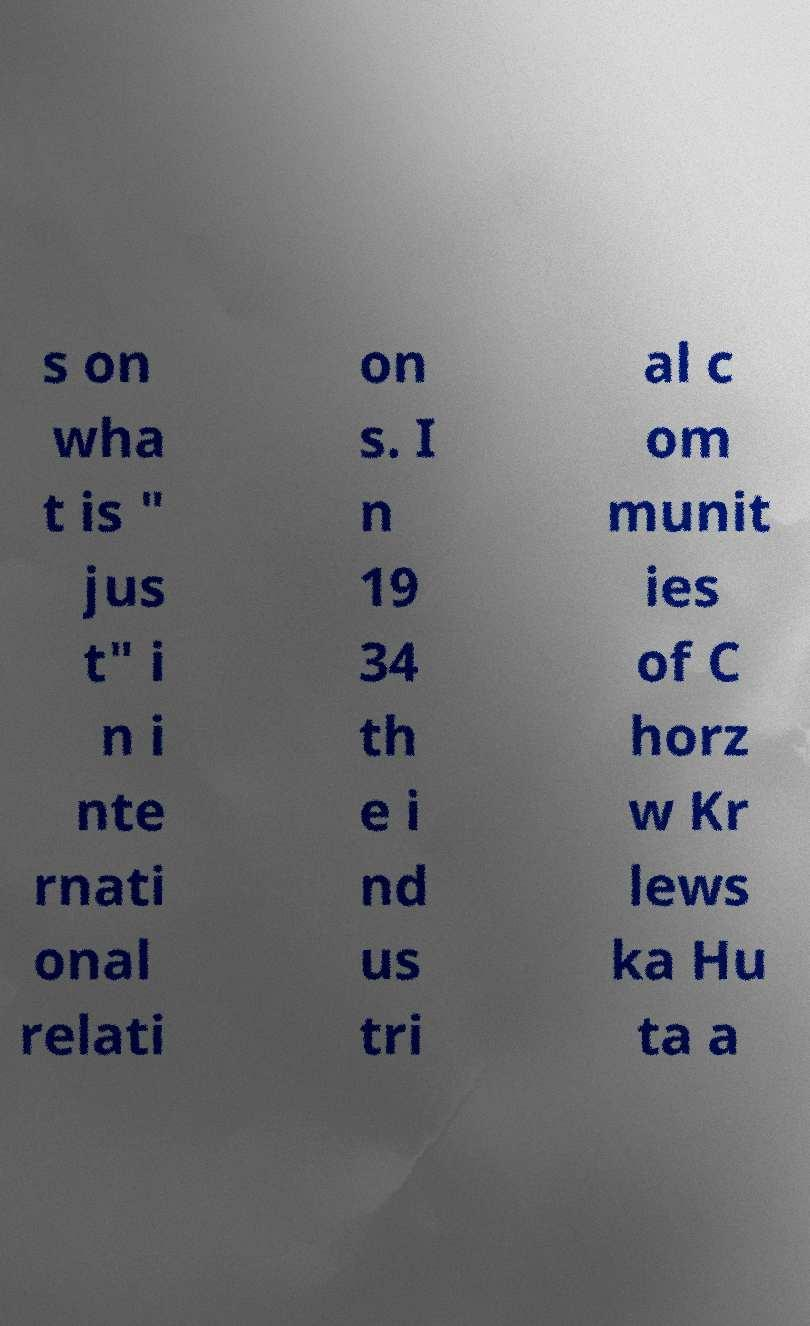Can you accurately transcribe the text from the provided image for me? s on wha t is " jus t" i n i nte rnati onal relati on s. I n 19 34 th e i nd us tri al c om munit ies of C horz w Kr lews ka Hu ta a 